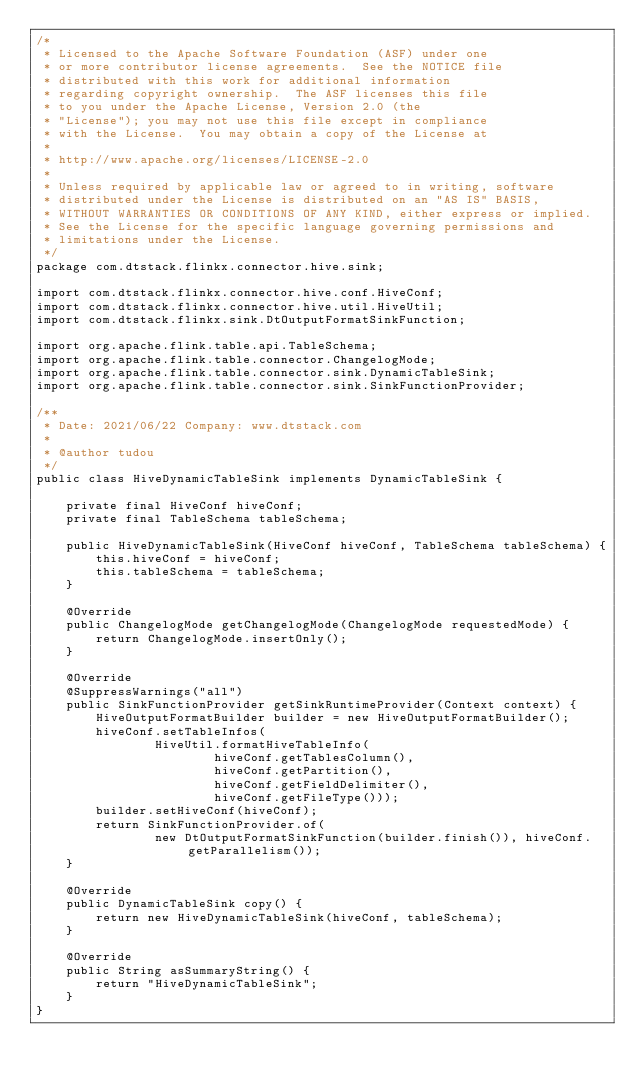Convert code to text. <code><loc_0><loc_0><loc_500><loc_500><_Java_>/*
 * Licensed to the Apache Software Foundation (ASF) under one
 * or more contributor license agreements.  See the NOTICE file
 * distributed with this work for additional information
 * regarding copyright ownership.  The ASF licenses this file
 * to you under the Apache License, Version 2.0 (the
 * "License"); you may not use this file except in compliance
 * with the License.  You may obtain a copy of the License at
 *
 * http://www.apache.org/licenses/LICENSE-2.0
 *
 * Unless required by applicable law or agreed to in writing, software
 * distributed under the License is distributed on an "AS IS" BASIS,
 * WITHOUT WARRANTIES OR CONDITIONS OF ANY KIND, either express or implied.
 * See the License for the specific language governing permissions and
 * limitations under the License.
 */
package com.dtstack.flinkx.connector.hive.sink;

import com.dtstack.flinkx.connector.hive.conf.HiveConf;
import com.dtstack.flinkx.connector.hive.util.HiveUtil;
import com.dtstack.flinkx.sink.DtOutputFormatSinkFunction;

import org.apache.flink.table.api.TableSchema;
import org.apache.flink.table.connector.ChangelogMode;
import org.apache.flink.table.connector.sink.DynamicTableSink;
import org.apache.flink.table.connector.sink.SinkFunctionProvider;

/**
 * Date: 2021/06/22 Company: www.dtstack.com
 *
 * @author tudou
 */
public class HiveDynamicTableSink implements DynamicTableSink {

    private final HiveConf hiveConf;
    private final TableSchema tableSchema;

    public HiveDynamicTableSink(HiveConf hiveConf, TableSchema tableSchema) {
        this.hiveConf = hiveConf;
        this.tableSchema = tableSchema;
    }

    @Override
    public ChangelogMode getChangelogMode(ChangelogMode requestedMode) {
        return ChangelogMode.insertOnly();
    }

    @Override
    @SuppressWarnings("all")
    public SinkFunctionProvider getSinkRuntimeProvider(Context context) {
        HiveOutputFormatBuilder builder = new HiveOutputFormatBuilder();
        hiveConf.setTableInfos(
                HiveUtil.formatHiveTableInfo(
                        hiveConf.getTablesColumn(),
                        hiveConf.getPartition(),
                        hiveConf.getFieldDelimiter(),
                        hiveConf.getFileType()));
        builder.setHiveConf(hiveConf);
        return SinkFunctionProvider.of(
                new DtOutputFormatSinkFunction(builder.finish()), hiveConf.getParallelism());
    }

    @Override
    public DynamicTableSink copy() {
        return new HiveDynamicTableSink(hiveConf, tableSchema);
    }

    @Override
    public String asSummaryString() {
        return "HiveDynamicTableSink";
    }
}
</code> 